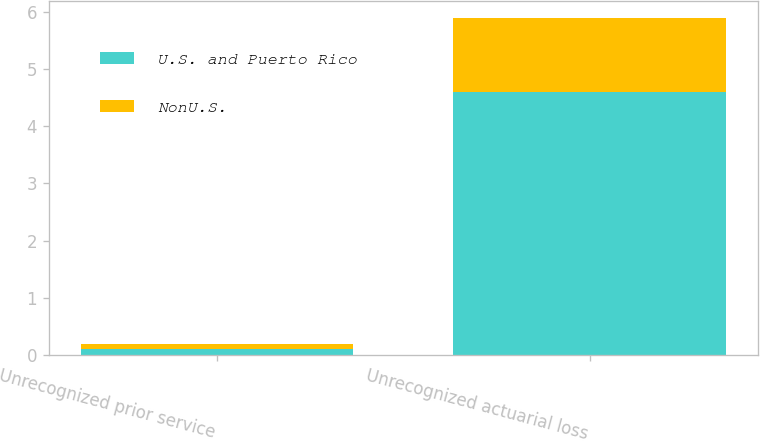Convert chart to OTSL. <chart><loc_0><loc_0><loc_500><loc_500><stacked_bar_chart><ecel><fcel>Unrecognized prior service<fcel>Unrecognized actuarial loss<nl><fcel>U.S. and Puerto Rico<fcel>0.1<fcel>4.6<nl><fcel>NonU.S.<fcel>0.1<fcel>1.3<nl></chart> 